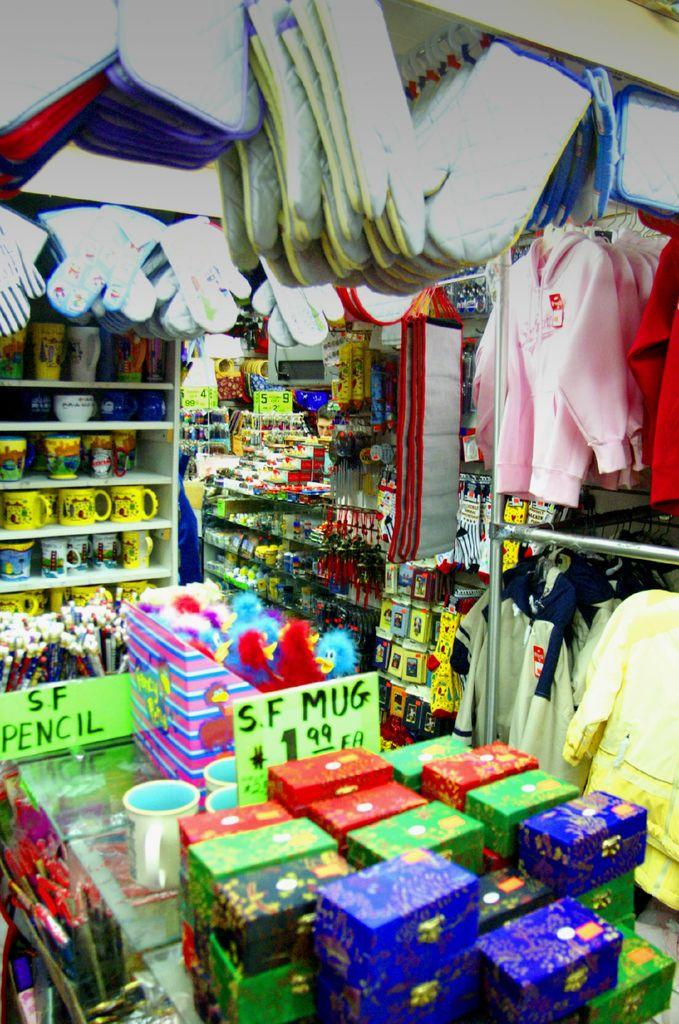What can be seen on the shelves in the image? Objects are placed on shelves in the image. Can you describe the arrangement of the objects on the shelves? Unfortunately, the provided facts do not give enough information to describe the arrangement of the objects on the shelves. What type of objects might be found on shelves in general? In general, shelves can hold various objects such as books, decorative items, or kitchenware. How many pigs are visible in the image? There are no pigs present in the image. What type of basket can be seen on the shelves in the image? There is no basket present on the shelves in the image. 